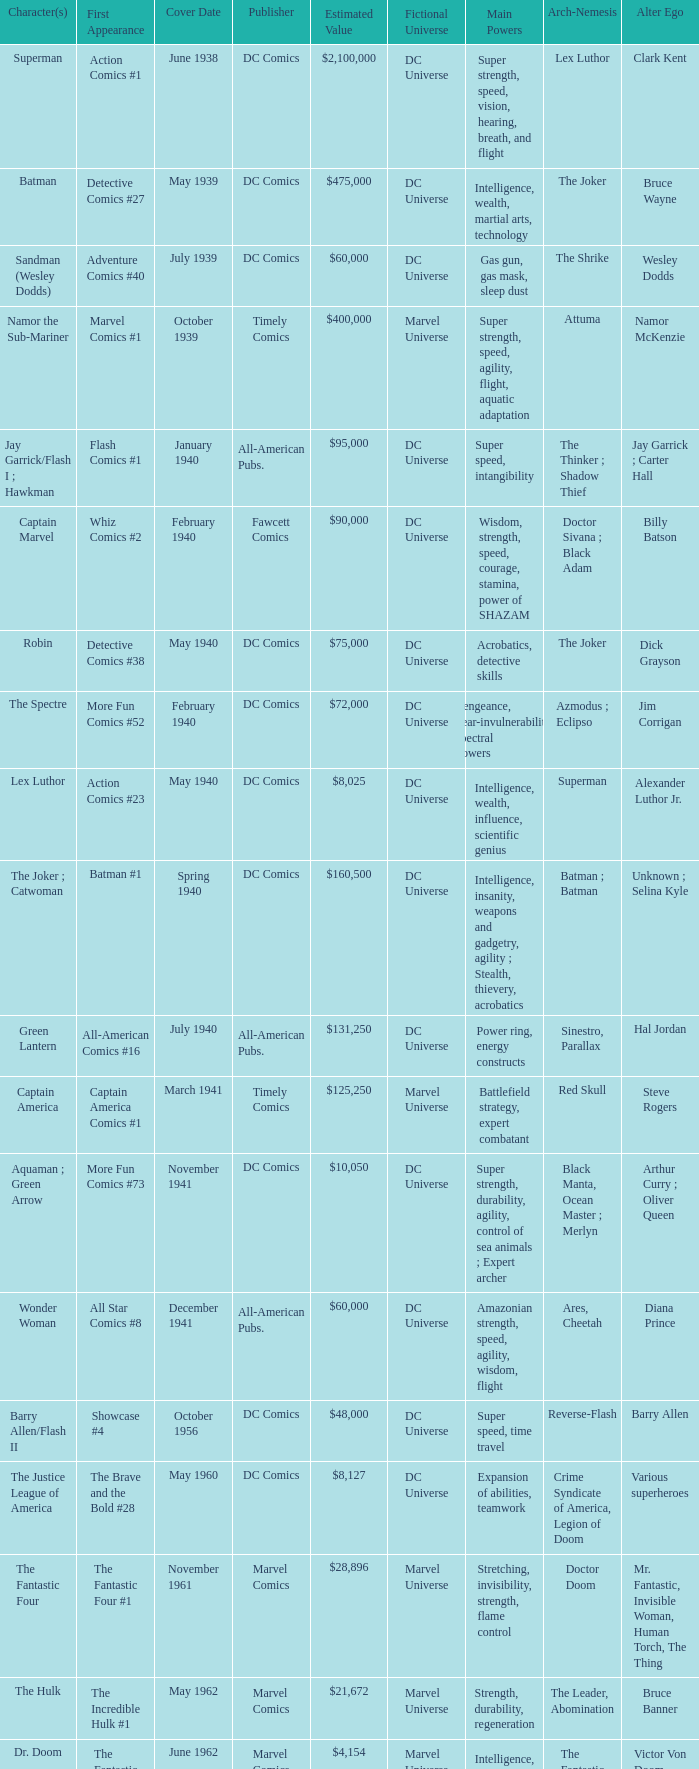What is Action Comics #1's estimated value? $2,100,000. 